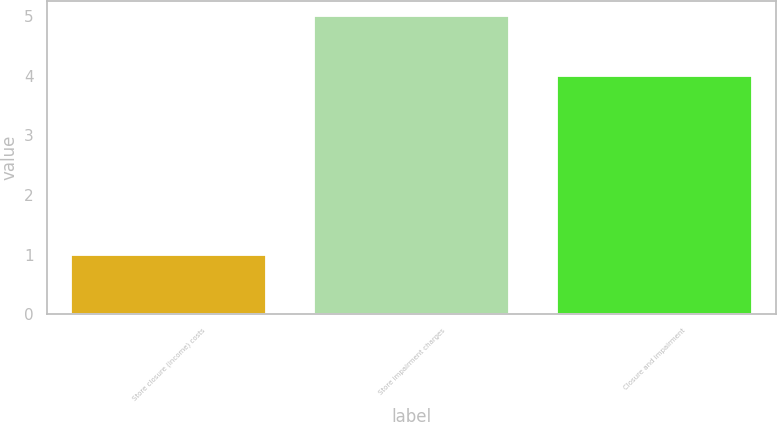Convert chart. <chart><loc_0><loc_0><loc_500><loc_500><bar_chart><fcel>Store closure (income) costs<fcel>Store impairment charges<fcel>Closure and impairment<nl><fcel>1<fcel>5<fcel>4<nl></chart> 